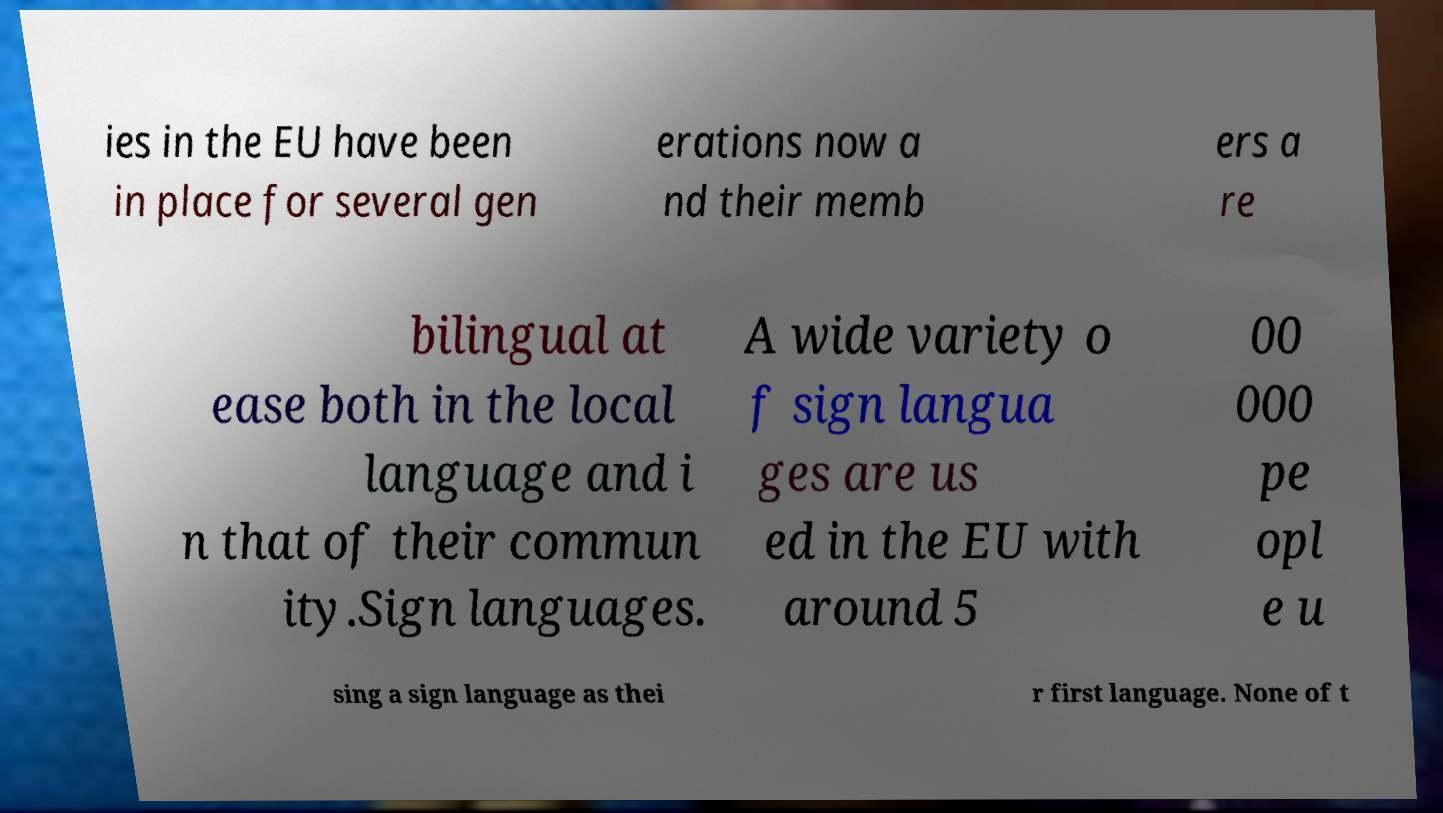Please identify and transcribe the text found in this image. ies in the EU have been in place for several gen erations now a nd their memb ers a re bilingual at ease both in the local language and i n that of their commun ity.Sign languages. A wide variety o f sign langua ges are us ed in the EU with around 5 00 000 pe opl e u sing a sign language as thei r first language. None of t 